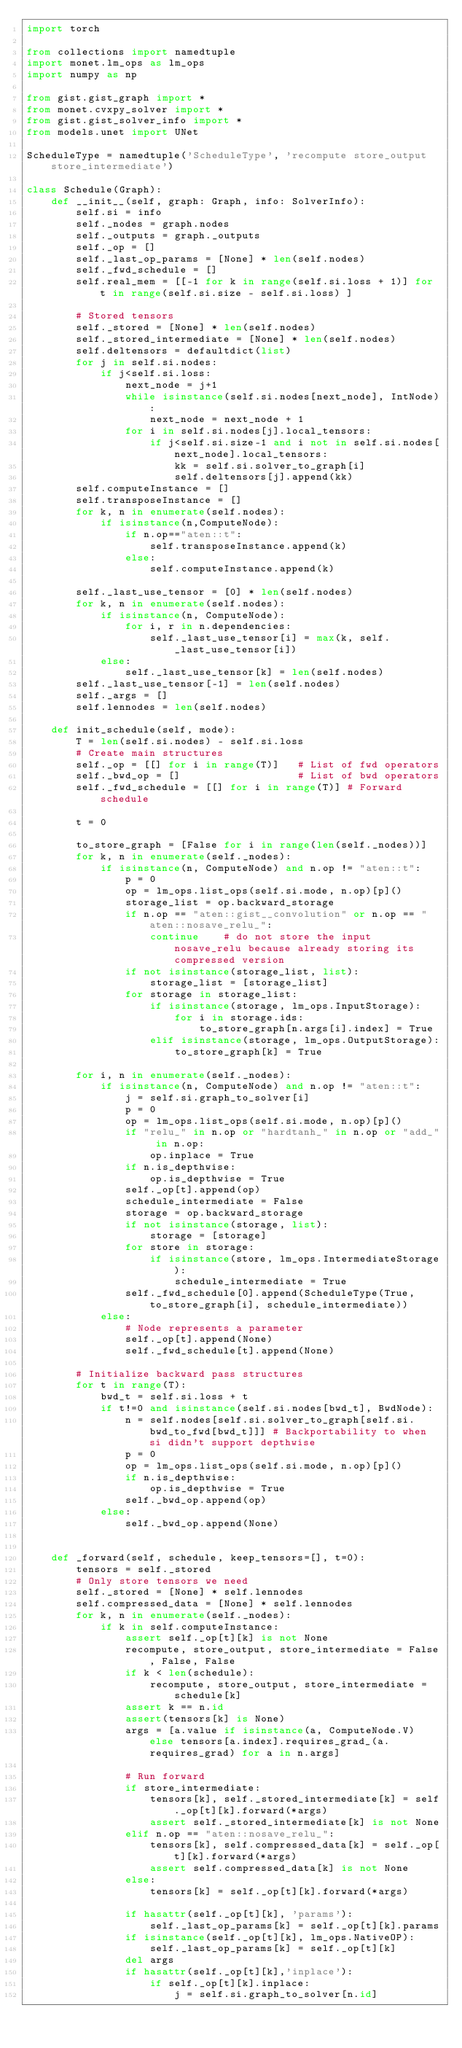Convert code to text. <code><loc_0><loc_0><loc_500><loc_500><_Python_>import torch

from collections import namedtuple
import monet.lm_ops as lm_ops
import numpy as np

from gist.gist_graph import *
from monet.cvxpy_solver import *
from gist.gist_solver_info import *
from models.unet import UNet

ScheduleType = namedtuple('ScheduleType', 'recompute store_output store_intermediate')

class Schedule(Graph):
    def __init__(self, graph: Graph, info: SolverInfo):
        self.si = info
        self._nodes = graph.nodes
        self._outputs = graph._outputs
        self._op = []
        self._last_op_params = [None] * len(self.nodes)
        self._fwd_schedule = []
        self.real_mem = [[-1 for k in range(self.si.loss + 1)] for t in range(self.si.size - self.si.loss) ]

        # Stored tensors
        self._stored = [None] * len(self.nodes)
        self._stored_intermediate = [None] * len(self.nodes)
        self.deltensors = defaultdict(list)
        for j in self.si.nodes:
            if j<self.si.loss:
                next_node = j+1
                while isinstance(self.si.nodes[next_node], IntNode):
                    next_node = next_node + 1
                for i in self.si.nodes[j].local_tensors:
                    if j<self.si.size-1 and i not in self.si.nodes[next_node].local_tensors:
                        kk = self.si.solver_to_graph[i]
                        self.deltensors[j].append(kk)
        self.computeInstance = []
        self.transposeInstance = []
        for k, n in enumerate(self.nodes):
            if isinstance(n,ComputeNode):
                if n.op=="aten::t":
                    self.transposeInstance.append(k)
                else:
                    self.computeInstance.append(k)

        self._last_use_tensor = [0] * len(self.nodes)
        for k, n in enumerate(self.nodes):
            if isinstance(n, ComputeNode):
                for i, r in n.dependencies:
                    self._last_use_tensor[i] = max(k, self._last_use_tensor[i])
            else:
                self._last_use_tensor[k] = len(self.nodes)
        self._last_use_tensor[-1] = len(self.nodes)
        self._args = []
        self.lennodes = len(self.nodes)

    def init_schedule(self, mode):
        T = len(self.si.nodes) - self.si.loss
        # Create main structures
        self._op = [[] for i in range(T)]   # List of fwd operators
        self._bwd_op = []                   # List of bwd operators
        self._fwd_schedule = [[] for i in range(T)] # Forward schedule

        t = 0

        to_store_graph = [False for i in range(len(self._nodes))]
        for k, n in enumerate(self._nodes):
            if isinstance(n, ComputeNode) and n.op != "aten::t":
                p = 0
                op = lm_ops.list_ops(self.si.mode, n.op)[p]()
                storage_list = op.backward_storage
                if n.op == "aten::gist__convolution" or n.op == "aten::nosave_relu_":
                    continue    # do not store the input nosave_relu because already storing its compressed version
                if not isinstance(storage_list, list):
                    storage_list = [storage_list]
                for storage in storage_list:
                    if isinstance(storage, lm_ops.InputStorage):
                        for i in storage.ids:
                            to_store_graph[n.args[i].index] = True
                    elif isinstance(storage, lm_ops.OutputStorage):
                        to_store_graph[k] = True

        for i, n in enumerate(self._nodes):
            if isinstance(n, ComputeNode) and n.op != "aten::t":
                j = self.si.graph_to_solver[i]
                p = 0
                op = lm_ops.list_ops(self.si.mode, n.op)[p]()
                if "relu_" in n.op or "hardtanh_" in n.op or "add_" in n.op:
                    op.inplace = True
                if n.is_depthwise:
                    op.is_depthwise = True
                self._op[t].append(op)
                schedule_intermediate = False
                storage = op.backward_storage
                if not isinstance(storage, list):
                    storage = [storage]
                for store in storage:
                    if isinstance(store, lm_ops.IntermediateStorage):
                        schedule_intermediate = True
                self._fwd_schedule[0].append(ScheduleType(True, to_store_graph[i], schedule_intermediate))
            else:
                # Node represents a parameter
                self._op[t].append(None)
                self._fwd_schedule[t].append(None)

        # Initialize backward pass structures
        for t in range(T):
            bwd_t = self.si.loss + t
            if t!=0 and isinstance(self.si.nodes[bwd_t], BwdNode):
                n = self.nodes[self.si.solver_to_graph[self.si.bwd_to_fwd[bwd_t]]] # Backportability to when si didn't support depthwise
                p = 0
                op = lm_ops.list_ops(self.si.mode, n.op)[p]()
                if n.is_depthwise:
                    op.is_depthwise = True
                self._bwd_op.append(op)
            else:
                self._bwd_op.append(None)


    def _forward(self, schedule, keep_tensors=[], t=0):
        tensors = self._stored
        # Only store tensors we need
        self._stored = [None] * self.lennodes
        self.compressed_data = [None] * self.lennodes
        for k, n in enumerate(self._nodes):
            if k in self.computeInstance:
                assert self._op[t][k] is not None
                recompute, store_output, store_intermediate = False, False, False
                if k < len(schedule):
                    recompute, store_output, store_intermediate = schedule[k]
                assert k == n.id
                assert(tensors[k] is None)
                args = [a.value if isinstance(a, ComputeNode.V) else tensors[a.index].requires_grad_(a.requires_grad) for a in n.args]

                # Run forward
                if store_intermediate:
                    tensors[k], self._stored_intermediate[k] = self._op[t][k].forward(*args)
                    assert self._stored_intermediate[k] is not None
                elif n.op == "aten::nosave_relu_":
                    tensors[k], self.compressed_data[k] = self._op[t][k].forward(*args)
                    assert self.compressed_data[k] is not None
                else:
                    tensors[k] = self._op[t][k].forward(*args)

                if hasattr(self._op[t][k], 'params'):
                    self._last_op_params[k] = self._op[t][k].params
                if isinstance(self._op[t][k], lm_ops.NativeOP):
                    self._last_op_params[k] = self._op[t][k]
                del args
                if hasattr(self._op[t][k],'inplace'):
                    if self._op[t][k].inplace:
                        j = self.si.graph_to_solver[n.id]</code> 